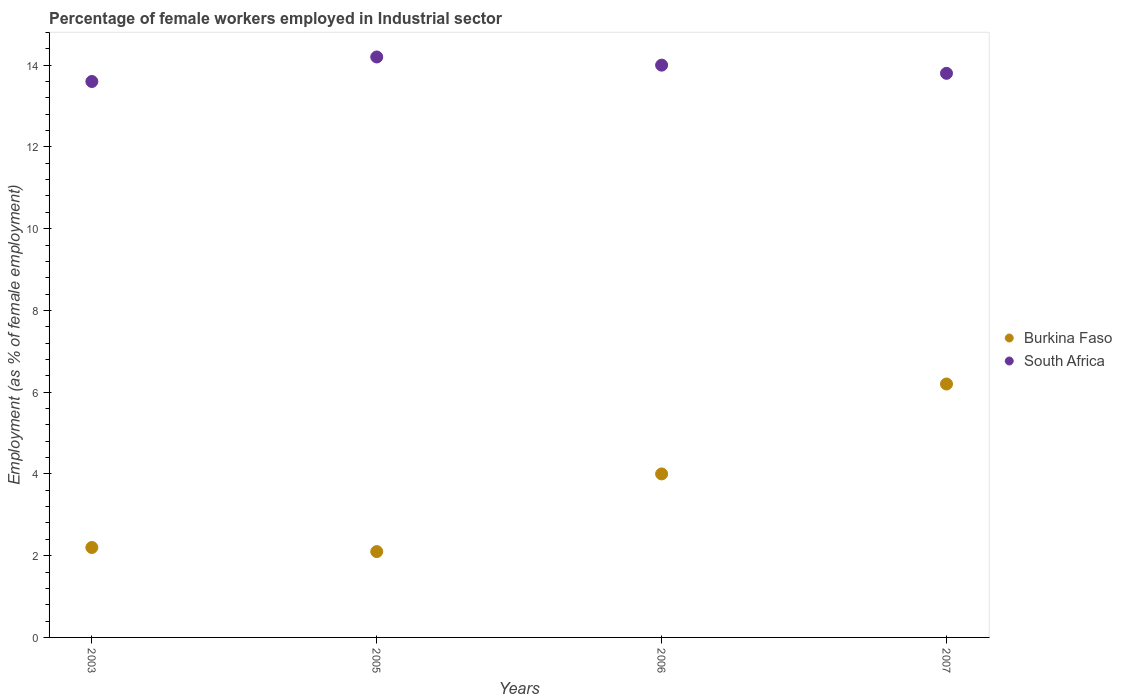What is the percentage of females employed in Industrial sector in Burkina Faso in 2007?
Provide a short and direct response. 6.2. Across all years, what is the maximum percentage of females employed in Industrial sector in South Africa?
Ensure brevity in your answer.  14.2. Across all years, what is the minimum percentage of females employed in Industrial sector in South Africa?
Your response must be concise. 13.6. In which year was the percentage of females employed in Industrial sector in Burkina Faso minimum?
Your answer should be very brief. 2005. What is the total percentage of females employed in Industrial sector in South Africa in the graph?
Keep it short and to the point. 55.6. What is the difference between the percentage of females employed in Industrial sector in Burkina Faso in 2003 and that in 2007?
Provide a short and direct response. -4. What is the difference between the percentage of females employed in Industrial sector in Burkina Faso in 2006 and the percentage of females employed in Industrial sector in South Africa in 2007?
Your answer should be very brief. -9.8. What is the average percentage of females employed in Industrial sector in South Africa per year?
Your answer should be very brief. 13.9. In the year 2003, what is the difference between the percentage of females employed in Industrial sector in Burkina Faso and percentage of females employed in Industrial sector in South Africa?
Your answer should be very brief. -11.4. In how many years, is the percentage of females employed in Industrial sector in South Africa greater than 10 %?
Make the answer very short. 4. What is the ratio of the percentage of females employed in Industrial sector in South Africa in 2003 to that in 2005?
Your answer should be very brief. 0.96. Is the percentage of females employed in Industrial sector in South Africa in 2003 less than that in 2005?
Provide a short and direct response. Yes. Is the difference between the percentage of females employed in Industrial sector in Burkina Faso in 2003 and 2005 greater than the difference between the percentage of females employed in Industrial sector in South Africa in 2003 and 2005?
Provide a short and direct response. Yes. What is the difference between the highest and the second highest percentage of females employed in Industrial sector in Burkina Faso?
Offer a terse response. 2.2. What is the difference between the highest and the lowest percentage of females employed in Industrial sector in South Africa?
Your answer should be compact. 0.6. Does the percentage of females employed in Industrial sector in Burkina Faso monotonically increase over the years?
Provide a short and direct response. No. Is the percentage of females employed in Industrial sector in South Africa strictly less than the percentage of females employed in Industrial sector in Burkina Faso over the years?
Ensure brevity in your answer.  No. How many dotlines are there?
Make the answer very short. 2. How many years are there in the graph?
Provide a succinct answer. 4. Does the graph contain any zero values?
Offer a terse response. No. Does the graph contain grids?
Provide a succinct answer. No. Where does the legend appear in the graph?
Ensure brevity in your answer.  Center right. How many legend labels are there?
Your response must be concise. 2. How are the legend labels stacked?
Your response must be concise. Vertical. What is the title of the graph?
Your response must be concise. Percentage of female workers employed in Industrial sector. What is the label or title of the X-axis?
Provide a short and direct response. Years. What is the label or title of the Y-axis?
Your answer should be compact. Employment (as % of female employment). What is the Employment (as % of female employment) in Burkina Faso in 2003?
Provide a succinct answer. 2.2. What is the Employment (as % of female employment) in South Africa in 2003?
Your response must be concise. 13.6. What is the Employment (as % of female employment) in Burkina Faso in 2005?
Give a very brief answer. 2.1. What is the Employment (as % of female employment) of South Africa in 2005?
Your answer should be very brief. 14.2. What is the Employment (as % of female employment) in Burkina Faso in 2007?
Offer a very short reply. 6.2. What is the Employment (as % of female employment) of South Africa in 2007?
Offer a terse response. 13.8. Across all years, what is the maximum Employment (as % of female employment) in Burkina Faso?
Provide a short and direct response. 6.2. Across all years, what is the maximum Employment (as % of female employment) of South Africa?
Offer a very short reply. 14.2. Across all years, what is the minimum Employment (as % of female employment) in Burkina Faso?
Make the answer very short. 2.1. Across all years, what is the minimum Employment (as % of female employment) of South Africa?
Make the answer very short. 13.6. What is the total Employment (as % of female employment) of Burkina Faso in the graph?
Your answer should be very brief. 14.5. What is the total Employment (as % of female employment) of South Africa in the graph?
Your answer should be compact. 55.6. What is the difference between the Employment (as % of female employment) of Burkina Faso in 2003 and that in 2006?
Provide a succinct answer. -1.8. What is the difference between the Employment (as % of female employment) in South Africa in 2003 and that in 2006?
Provide a succinct answer. -0.4. What is the difference between the Employment (as % of female employment) in Burkina Faso in 2003 and that in 2007?
Offer a terse response. -4. What is the difference between the Employment (as % of female employment) of South Africa in 2003 and that in 2007?
Provide a short and direct response. -0.2. What is the difference between the Employment (as % of female employment) of Burkina Faso in 2005 and that in 2006?
Your response must be concise. -1.9. What is the difference between the Employment (as % of female employment) of South Africa in 2005 and that in 2006?
Provide a short and direct response. 0.2. What is the difference between the Employment (as % of female employment) in Burkina Faso in 2003 and the Employment (as % of female employment) in South Africa in 2006?
Provide a short and direct response. -11.8. What is the difference between the Employment (as % of female employment) in Burkina Faso in 2003 and the Employment (as % of female employment) in South Africa in 2007?
Provide a short and direct response. -11.6. What is the difference between the Employment (as % of female employment) of Burkina Faso in 2005 and the Employment (as % of female employment) of South Africa in 2006?
Your answer should be compact. -11.9. What is the difference between the Employment (as % of female employment) of Burkina Faso in 2005 and the Employment (as % of female employment) of South Africa in 2007?
Your answer should be compact. -11.7. What is the difference between the Employment (as % of female employment) of Burkina Faso in 2006 and the Employment (as % of female employment) of South Africa in 2007?
Make the answer very short. -9.8. What is the average Employment (as % of female employment) of Burkina Faso per year?
Give a very brief answer. 3.62. What is the average Employment (as % of female employment) of South Africa per year?
Offer a very short reply. 13.9. In the year 2003, what is the difference between the Employment (as % of female employment) in Burkina Faso and Employment (as % of female employment) in South Africa?
Your answer should be very brief. -11.4. In the year 2005, what is the difference between the Employment (as % of female employment) of Burkina Faso and Employment (as % of female employment) of South Africa?
Your answer should be very brief. -12.1. In the year 2007, what is the difference between the Employment (as % of female employment) of Burkina Faso and Employment (as % of female employment) of South Africa?
Make the answer very short. -7.6. What is the ratio of the Employment (as % of female employment) in Burkina Faso in 2003 to that in 2005?
Give a very brief answer. 1.05. What is the ratio of the Employment (as % of female employment) of South Africa in 2003 to that in 2005?
Offer a terse response. 0.96. What is the ratio of the Employment (as % of female employment) in Burkina Faso in 2003 to that in 2006?
Your answer should be very brief. 0.55. What is the ratio of the Employment (as % of female employment) of South Africa in 2003 to that in 2006?
Offer a terse response. 0.97. What is the ratio of the Employment (as % of female employment) of Burkina Faso in 2003 to that in 2007?
Keep it short and to the point. 0.35. What is the ratio of the Employment (as % of female employment) in South Africa in 2003 to that in 2007?
Your answer should be very brief. 0.99. What is the ratio of the Employment (as % of female employment) of Burkina Faso in 2005 to that in 2006?
Your response must be concise. 0.53. What is the ratio of the Employment (as % of female employment) of South Africa in 2005 to that in 2006?
Your answer should be compact. 1.01. What is the ratio of the Employment (as % of female employment) of Burkina Faso in 2005 to that in 2007?
Offer a terse response. 0.34. What is the ratio of the Employment (as % of female employment) of South Africa in 2005 to that in 2007?
Give a very brief answer. 1.03. What is the ratio of the Employment (as % of female employment) of Burkina Faso in 2006 to that in 2007?
Give a very brief answer. 0.65. What is the ratio of the Employment (as % of female employment) of South Africa in 2006 to that in 2007?
Your response must be concise. 1.01. What is the difference between the highest and the lowest Employment (as % of female employment) of Burkina Faso?
Provide a succinct answer. 4.1. 